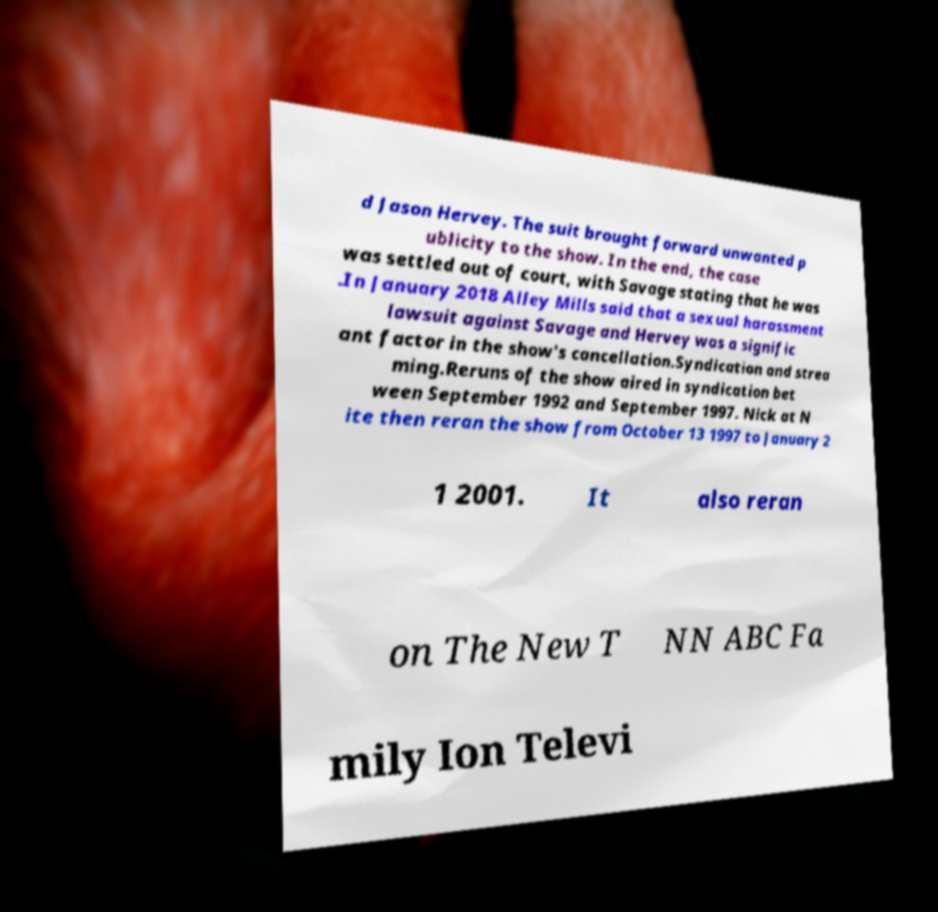Please read and relay the text visible in this image. What does it say? d Jason Hervey. The suit brought forward unwanted p ublicity to the show. In the end, the case was settled out of court, with Savage stating that he was .In January 2018 Alley Mills said that a sexual harassment lawsuit against Savage and Hervey was a signific ant factor in the show's cancellation.Syndication and strea ming.Reruns of the show aired in syndication bet ween September 1992 and September 1997. Nick at N ite then reran the show from October 13 1997 to January 2 1 2001. It also reran on The New T NN ABC Fa mily Ion Televi 